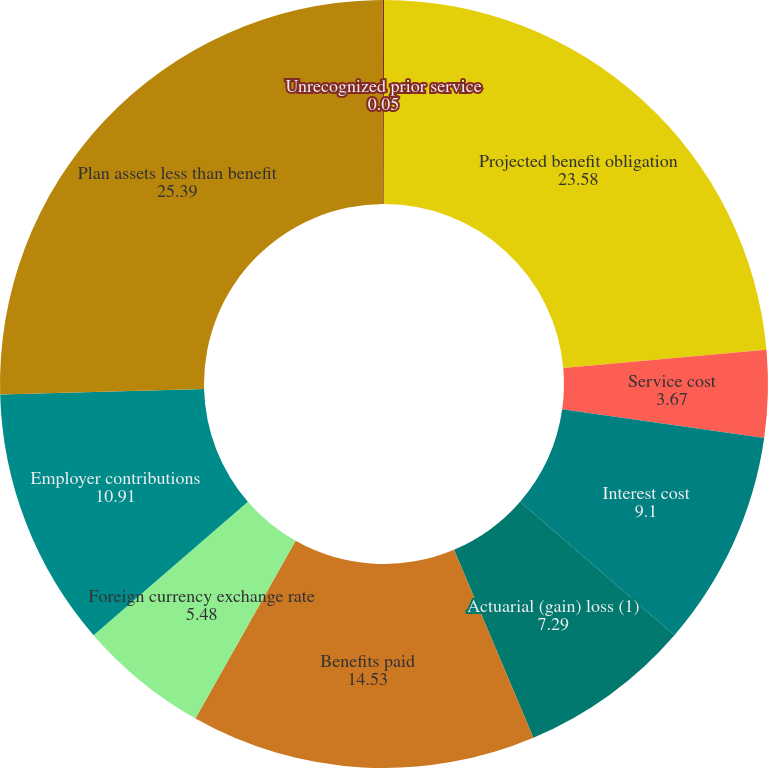Convert chart. <chart><loc_0><loc_0><loc_500><loc_500><pie_chart><fcel>Projected benefit obligation<fcel>Service cost<fcel>Interest cost<fcel>Actuarial (gain) loss (1)<fcel>Benefits paid<fcel>Foreign currency exchange rate<fcel>Employer contributions<fcel>Plan assets less than benefit<fcel>Unrecognized prior service<nl><fcel>23.58%<fcel>3.67%<fcel>9.1%<fcel>7.29%<fcel>14.53%<fcel>5.48%<fcel>10.91%<fcel>25.39%<fcel>0.05%<nl></chart> 